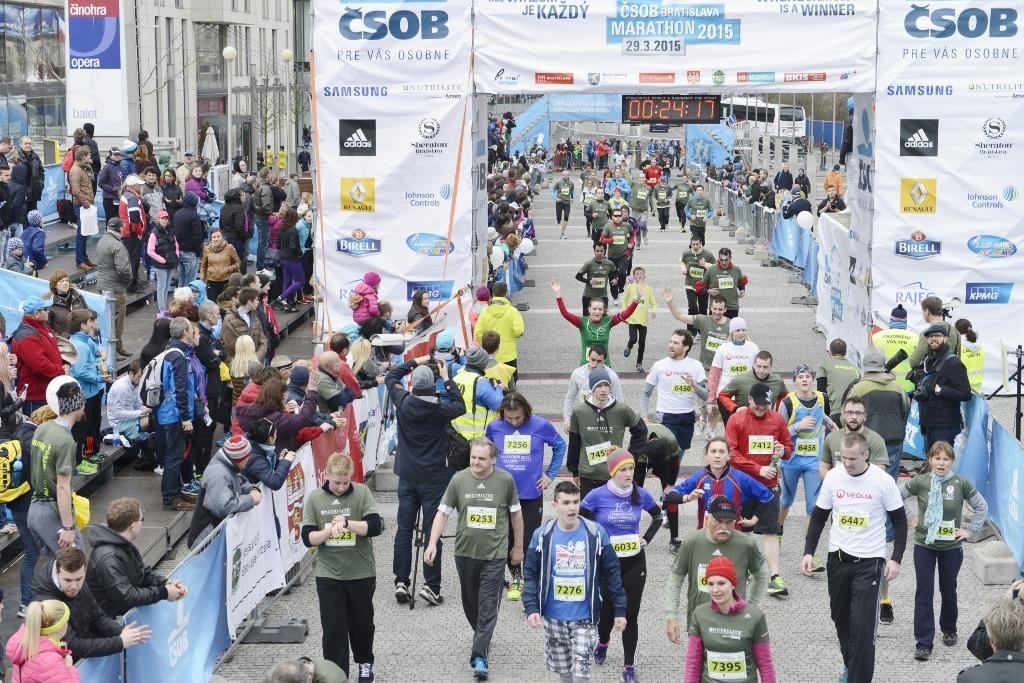What are the people in the image doing? The people in the image are walking. What can be seen hanging or displayed in the image? There are banners in the image. What type of structures are visible in the image? There are buildings in the image. What type of lighting is present in the image? There are street lamps in the image. What mode of transportation can be seen in the background of the image? There is a bus in the background of the image. What chess piece is the person in the image holding? There is no chess piece present in the image; people are walking and there are no objects being held. 